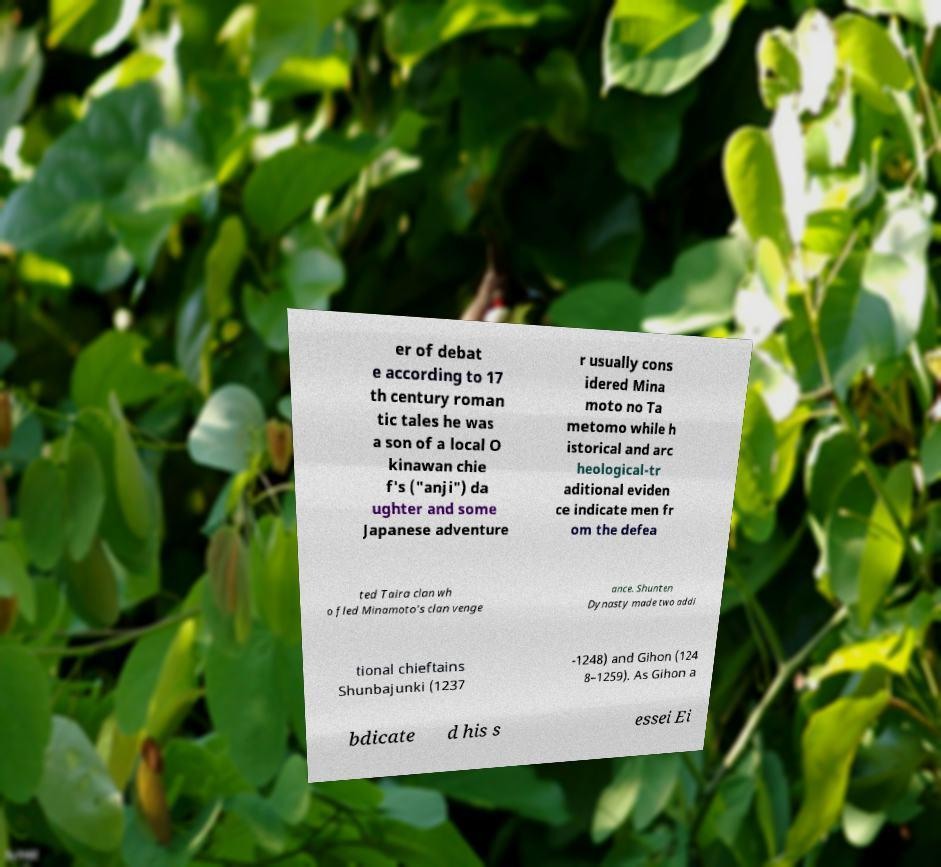I need the written content from this picture converted into text. Can you do that? er of debat e according to 17 th century roman tic tales he was a son of a local O kinawan chie f's ("anji") da ughter and some Japanese adventure r usually cons idered Mina moto no Ta metomo while h istorical and arc heological-tr aditional eviden ce indicate men fr om the defea ted Taira clan wh o fled Minamoto's clan venge ance. Shunten Dynasty made two addi tional chieftains Shunbajunki (1237 -1248) and Gihon (124 8–1259). As Gihon a bdicate d his s essei Ei 